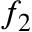Convert formula to latex. <formula><loc_0><loc_0><loc_500><loc_500>f _ { 2 }</formula> 